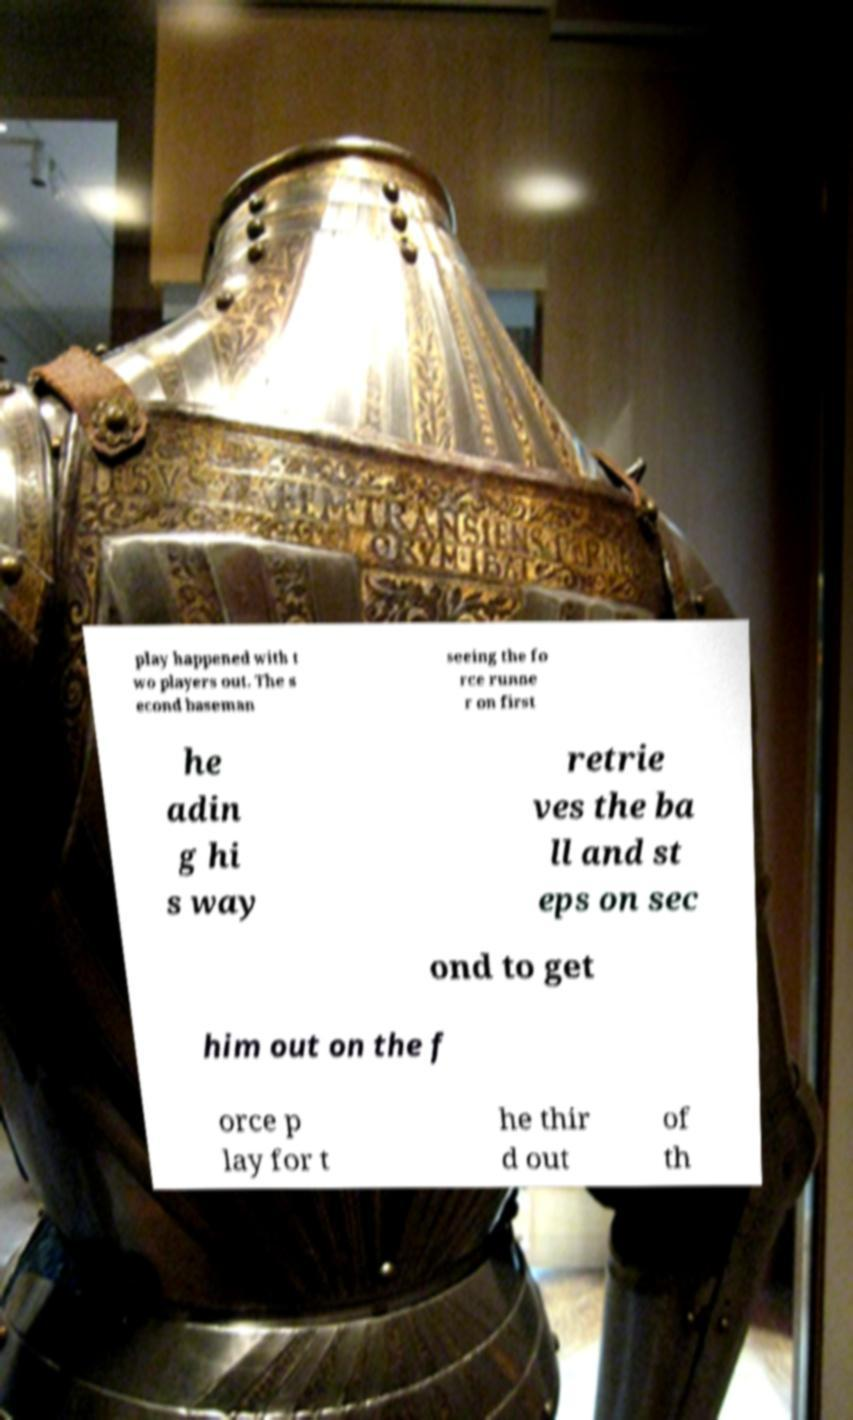Could you extract and type out the text from this image? play happened with t wo players out. The s econd baseman seeing the fo rce runne r on first he adin g hi s way retrie ves the ba ll and st eps on sec ond to get him out on the f orce p lay for t he thir d out of th 